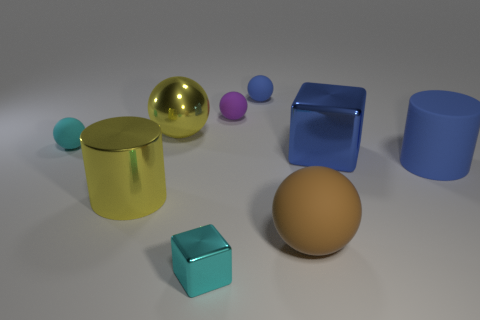What might the context be for this collection of objects - is there any indication they are part of a set for a specific purpose? There's no clear indication that these objects are part of a set for a specific purpose. They appear to be a random assemblage of geometric shapes perhaps chosen for a study in shape, color, and reflection, commonly used in a rendering software showcase or a test for 3D modeling and lighting. 